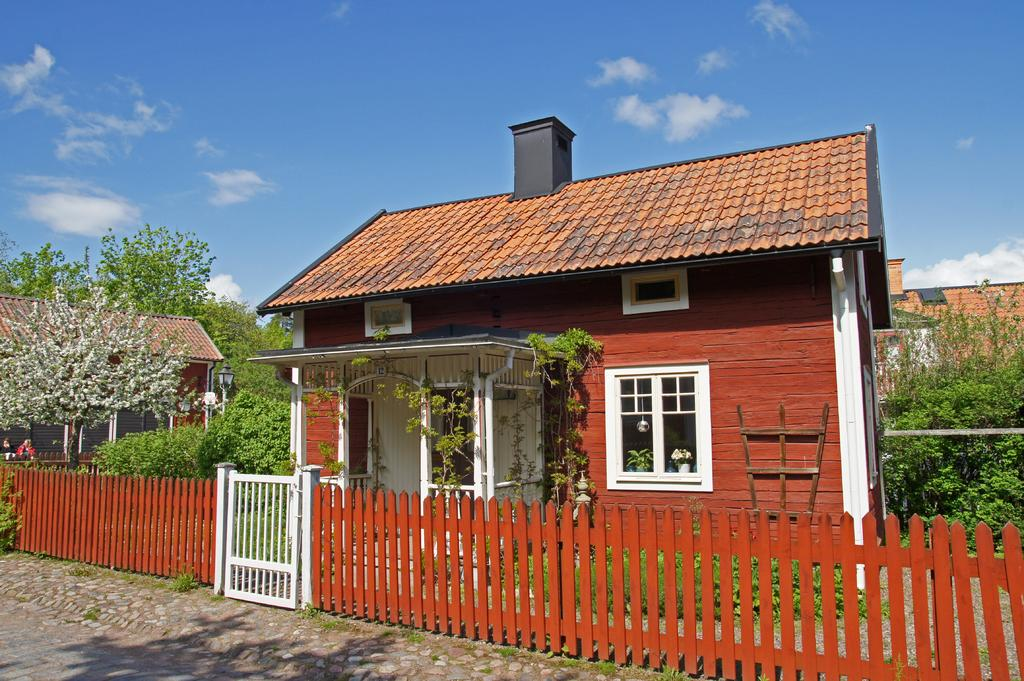What type of surface can be seen in the image? There is ground visible in the image. What is located beside the ground? There is a fence beside the ground. What type of structures are present in the image? There are houses in the image. What type of vegetation is present in the image? There are trees in the image. Who or what else can be seen in the image? There are people in the image. What is visible in the background of the image? The sky is visible in the background of the image, and clouds are present in the sky. How many eyes does the kitten have in the image? There is no kitten present in the image, so it is not possible to determine the number of eyes it might have. 